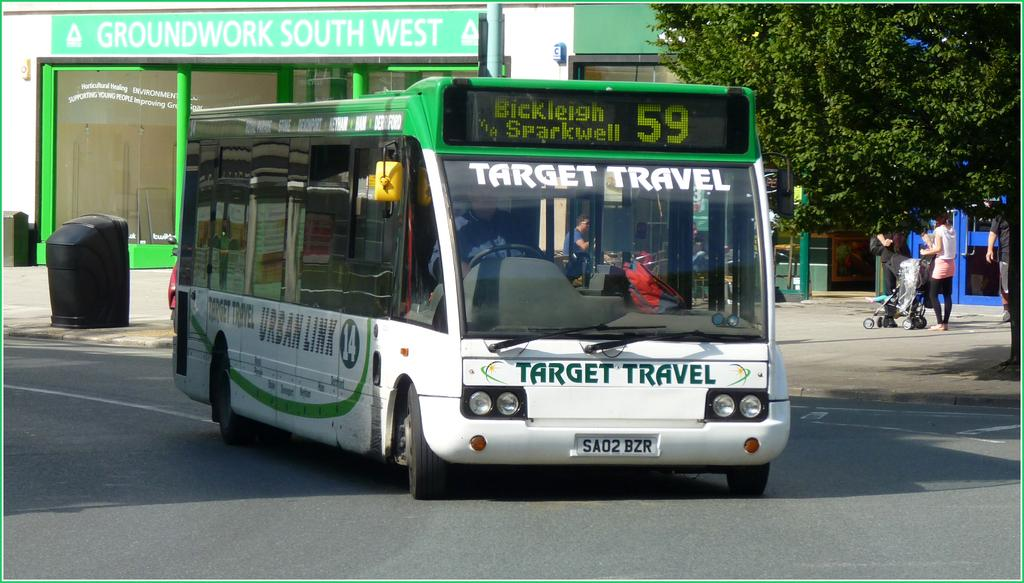What type of vehicle is on the road in the image? There is a bus on the road in the image. What are the people in the image doing? The people in the image are standing. What type of plant can be seen in the image? There is a green tree in the image. What type of disgust can be seen on the faces of the people in the image? There is no indication of disgust on the faces of the people in the image; they are simply standing. 